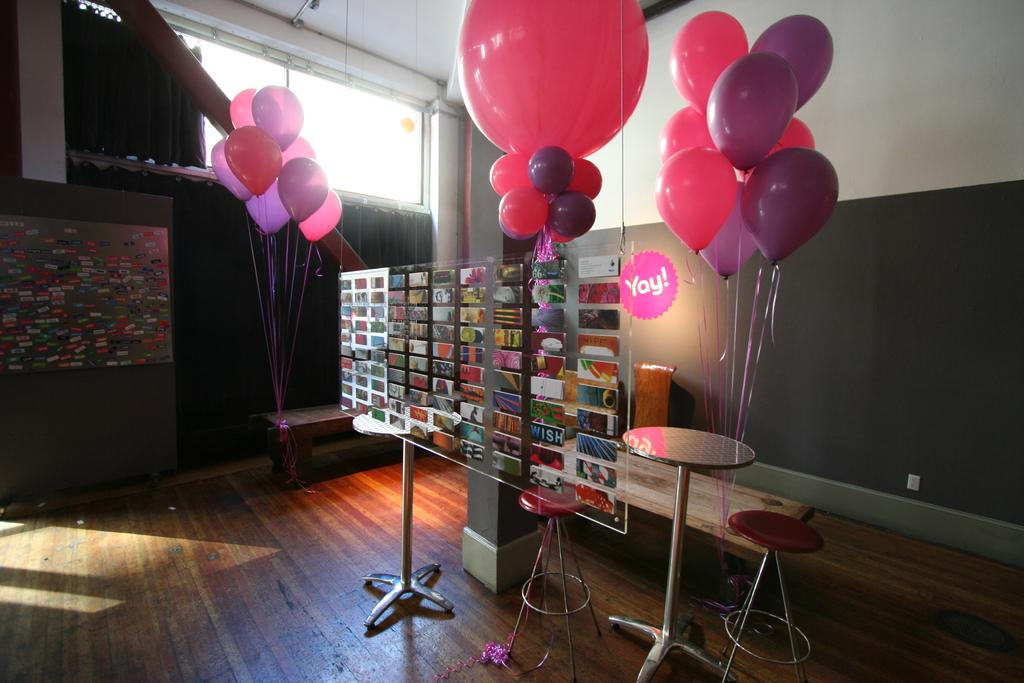<image>
Describe the image concisely. Pink and purple balloons decorate a room with a yay sign hanging up. 